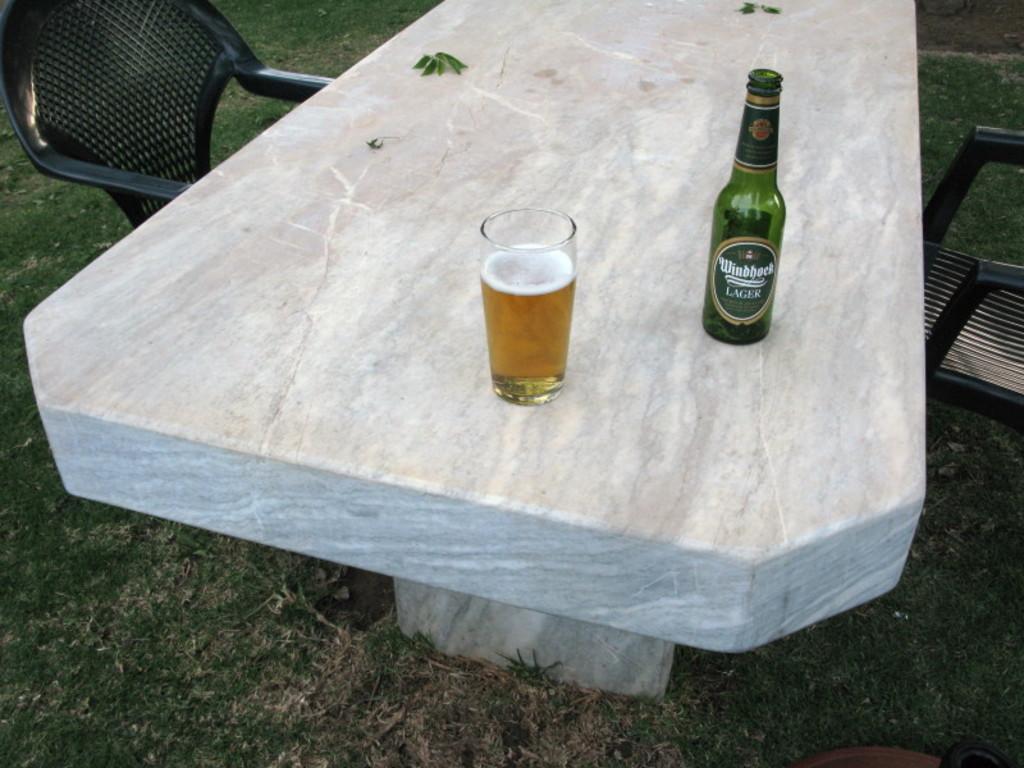Can you describe this image briefly? In this image there are two chairs on the right and left side, and one table is there. On the table there is one bottle and glass is there that glass is filled with drink and in the bottom there is grass. 